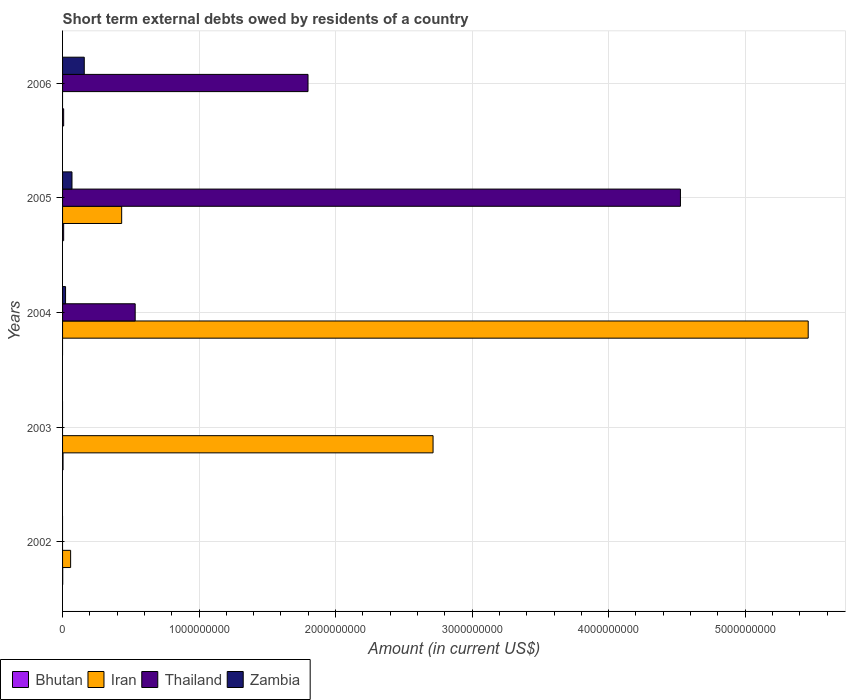How many groups of bars are there?
Offer a very short reply. 5. Are the number of bars per tick equal to the number of legend labels?
Give a very brief answer. No. Are the number of bars on each tick of the Y-axis equal?
Give a very brief answer. No. How many bars are there on the 2nd tick from the top?
Offer a terse response. 4. What is the amount of short-term external debts owed by residents in Thailand in 2005?
Your response must be concise. 4.53e+09. Across all years, what is the minimum amount of short-term external debts owed by residents in Bhutan?
Offer a very short reply. 0. What is the total amount of short-term external debts owed by residents in Thailand in the graph?
Give a very brief answer. 6.86e+09. What is the difference between the amount of short-term external debts owed by residents in Iran in 2002 and that in 2005?
Offer a terse response. -3.74e+08. What is the difference between the amount of short-term external debts owed by residents in Iran in 2004 and the amount of short-term external debts owed by residents in Bhutan in 2005?
Make the answer very short. 5.45e+09. What is the average amount of short-term external debts owed by residents in Thailand per year?
Your answer should be compact. 1.37e+09. In the year 2005, what is the difference between the amount of short-term external debts owed by residents in Thailand and amount of short-term external debts owed by residents in Bhutan?
Your response must be concise. 4.52e+09. What is the ratio of the amount of short-term external debts owed by residents in Zambia in 2004 to that in 2006?
Provide a short and direct response. 0.14. Is the difference between the amount of short-term external debts owed by residents in Thailand in 2005 and 2006 greater than the difference between the amount of short-term external debts owed by residents in Bhutan in 2005 and 2006?
Ensure brevity in your answer.  Yes. What is the difference between the highest and the lowest amount of short-term external debts owed by residents in Zambia?
Provide a succinct answer. 1.59e+08. Is it the case that in every year, the sum of the amount of short-term external debts owed by residents in Iran and amount of short-term external debts owed by residents in Bhutan is greater than the sum of amount of short-term external debts owed by residents in Zambia and amount of short-term external debts owed by residents in Thailand?
Provide a short and direct response. No. Is it the case that in every year, the sum of the amount of short-term external debts owed by residents in Iran and amount of short-term external debts owed by residents in Bhutan is greater than the amount of short-term external debts owed by residents in Thailand?
Provide a short and direct response. No. Are all the bars in the graph horizontal?
Your answer should be compact. Yes. Does the graph contain any zero values?
Your response must be concise. Yes. Does the graph contain grids?
Keep it short and to the point. Yes. Where does the legend appear in the graph?
Provide a short and direct response. Bottom left. How many legend labels are there?
Provide a short and direct response. 4. How are the legend labels stacked?
Make the answer very short. Horizontal. What is the title of the graph?
Make the answer very short. Short term external debts owed by residents of a country. Does "Myanmar" appear as one of the legend labels in the graph?
Your answer should be very brief. No. What is the label or title of the X-axis?
Offer a terse response. Amount (in current US$). What is the Amount (in current US$) in Bhutan in 2002?
Offer a very short reply. 9.93e+05. What is the Amount (in current US$) in Iran in 2002?
Your answer should be very brief. 5.90e+07. What is the Amount (in current US$) of Thailand in 2002?
Provide a short and direct response. 0. What is the Amount (in current US$) in Bhutan in 2003?
Your response must be concise. 3.38e+06. What is the Amount (in current US$) in Iran in 2003?
Make the answer very short. 2.71e+09. What is the Amount (in current US$) of Bhutan in 2004?
Give a very brief answer. 0. What is the Amount (in current US$) of Iran in 2004?
Provide a succinct answer. 5.46e+09. What is the Amount (in current US$) in Thailand in 2004?
Keep it short and to the point. 5.32e+08. What is the Amount (in current US$) in Zambia in 2004?
Offer a terse response. 2.20e+07. What is the Amount (in current US$) of Bhutan in 2005?
Provide a short and direct response. 8.00e+06. What is the Amount (in current US$) in Iran in 2005?
Offer a terse response. 4.33e+08. What is the Amount (in current US$) of Thailand in 2005?
Your answer should be very brief. 4.53e+09. What is the Amount (in current US$) in Zambia in 2005?
Offer a very short reply. 6.90e+07. What is the Amount (in current US$) in Thailand in 2006?
Provide a succinct answer. 1.80e+09. What is the Amount (in current US$) in Zambia in 2006?
Give a very brief answer. 1.59e+08. Across all years, what is the maximum Amount (in current US$) in Iran?
Provide a succinct answer. 5.46e+09. Across all years, what is the maximum Amount (in current US$) in Thailand?
Provide a succinct answer. 4.53e+09. Across all years, what is the maximum Amount (in current US$) of Zambia?
Give a very brief answer. 1.59e+08. Across all years, what is the minimum Amount (in current US$) of Thailand?
Keep it short and to the point. 0. What is the total Amount (in current US$) in Bhutan in the graph?
Give a very brief answer. 2.04e+07. What is the total Amount (in current US$) in Iran in the graph?
Offer a very short reply. 8.67e+09. What is the total Amount (in current US$) in Thailand in the graph?
Provide a succinct answer. 6.86e+09. What is the total Amount (in current US$) in Zambia in the graph?
Offer a very short reply. 2.50e+08. What is the difference between the Amount (in current US$) of Bhutan in 2002 and that in 2003?
Provide a succinct answer. -2.38e+06. What is the difference between the Amount (in current US$) of Iran in 2002 and that in 2003?
Provide a short and direct response. -2.66e+09. What is the difference between the Amount (in current US$) of Iran in 2002 and that in 2004?
Keep it short and to the point. -5.40e+09. What is the difference between the Amount (in current US$) in Bhutan in 2002 and that in 2005?
Keep it short and to the point. -7.01e+06. What is the difference between the Amount (in current US$) in Iran in 2002 and that in 2005?
Offer a very short reply. -3.74e+08. What is the difference between the Amount (in current US$) of Bhutan in 2002 and that in 2006?
Offer a very short reply. -7.01e+06. What is the difference between the Amount (in current US$) in Iran in 2003 and that in 2004?
Give a very brief answer. -2.75e+09. What is the difference between the Amount (in current US$) of Bhutan in 2003 and that in 2005?
Make the answer very short. -4.62e+06. What is the difference between the Amount (in current US$) in Iran in 2003 and that in 2005?
Offer a terse response. 2.28e+09. What is the difference between the Amount (in current US$) of Bhutan in 2003 and that in 2006?
Provide a succinct answer. -4.62e+06. What is the difference between the Amount (in current US$) of Iran in 2004 and that in 2005?
Your answer should be very brief. 5.03e+09. What is the difference between the Amount (in current US$) of Thailand in 2004 and that in 2005?
Your response must be concise. -3.99e+09. What is the difference between the Amount (in current US$) of Zambia in 2004 and that in 2005?
Offer a very short reply. -4.70e+07. What is the difference between the Amount (in current US$) in Thailand in 2004 and that in 2006?
Make the answer very short. -1.27e+09. What is the difference between the Amount (in current US$) in Zambia in 2004 and that in 2006?
Make the answer very short. -1.37e+08. What is the difference between the Amount (in current US$) in Bhutan in 2005 and that in 2006?
Provide a short and direct response. 0. What is the difference between the Amount (in current US$) in Thailand in 2005 and that in 2006?
Keep it short and to the point. 2.73e+09. What is the difference between the Amount (in current US$) of Zambia in 2005 and that in 2006?
Make the answer very short. -9.00e+07. What is the difference between the Amount (in current US$) in Bhutan in 2002 and the Amount (in current US$) in Iran in 2003?
Your answer should be very brief. -2.71e+09. What is the difference between the Amount (in current US$) in Bhutan in 2002 and the Amount (in current US$) in Iran in 2004?
Offer a very short reply. -5.46e+09. What is the difference between the Amount (in current US$) of Bhutan in 2002 and the Amount (in current US$) of Thailand in 2004?
Give a very brief answer. -5.31e+08. What is the difference between the Amount (in current US$) of Bhutan in 2002 and the Amount (in current US$) of Zambia in 2004?
Offer a very short reply. -2.10e+07. What is the difference between the Amount (in current US$) in Iran in 2002 and the Amount (in current US$) in Thailand in 2004?
Offer a terse response. -4.73e+08. What is the difference between the Amount (in current US$) in Iran in 2002 and the Amount (in current US$) in Zambia in 2004?
Your answer should be very brief. 3.70e+07. What is the difference between the Amount (in current US$) in Bhutan in 2002 and the Amount (in current US$) in Iran in 2005?
Keep it short and to the point. -4.32e+08. What is the difference between the Amount (in current US$) in Bhutan in 2002 and the Amount (in current US$) in Thailand in 2005?
Offer a terse response. -4.53e+09. What is the difference between the Amount (in current US$) of Bhutan in 2002 and the Amount (in current US$) of Zambia in 2005?
Your answer should be very brief. -6.80e+07. What is the difference between the Amount (in current US$) of Iran in 2002 and the Amount (in current US$) of Thailand in 2005?
Your answer should be compact. -4.47e+09. What is the difference between the Amount (in current US$) in Iran in 2002 and the Amount (in current US$) in Zambia in 2005?
Give a very brief answer. -1.00e+07. What is the difference between the Amount (in current US$) in Bhutan in 2002 and the Amount (in current US$) in Thailand in 2006?
Ensure brevity in your answer.  -1.80e+09. What is the difference between the Amount (in current US$) of Bhutan in 2002 and the Amount (in current US$) of Zambia in 2006?
Provide a succinct answer. -1.58e+08. What is the difference between the Amount (in current US$) in Iran in 2002 and the Amount (in current US$) in Thailand in 2006?
Your answer should be very brief. -1.74e+09. What is the difference between the Amount (in current US$) of Iran in 2002 and the Amount (in current US$) of Zambia in 2006?
Give a very brief answer. -1.00e+08. What is the difference between the Amount (in current US$) of Bhutan in 2003 and the Amount (in current US$) of Iran in 2004?
Provide a succinct answer. -5.46e+09. What is the difference between the Amount (in current US$) of Bhutan in 2003 and the Amount (in current US$) of Thailand in 2004?
Your response must be concise. -5.29e+08. What is the difference between the Amount (in current US$) in Bhutan in 2003 and the Amount (in current US$) in Zambia in 2004?
Keep it short and to the point. -1.86e+07. What is the difference between the Amount (in current US$) in Iran in 2003 and the Amount (in current US$) in Thailand in 2004?
Keep it short and to the point. 2.18e+09. What is the difference between the Amount (in current US$) of Iran in 2003 and the Amount (in current US$) of Zambia in 2004?
Your response must be concise. 2.69e+09. What is the difference between the Amount (in current US$) of Bhutan in 2003 and the Amount (in current US$) of Iran in 2005?
Give a very brief answer. -4.30e+08. What is the difference between the Amount (in current US$) of Bhutan in 2003 and the Amount (in current US$) of Thailand in 2005?
Your answer should be very brief. -4.52e+09. What is the difference between the Amount (in current US$) in Bhutan in 2003 and the Amount (in current US$) in Zambia in 2005?
Provide a succinct answer. -6.56e+07. What is the difference between the Amount (in current US$) in Iran in 2003 and the Amount (in current US$) in Thailand in 2005?
Offer a very short reply. -1.81e+09. What is the difference between the Amount (in current US$) in Iran in 2003 and the Amount (in current US$) in Zambia in 2005?
Provide a succinct answer. 2.64e+09. What is the difference between the Amount (in current US$) of Bhutan in 2003 and the Amount (in current US$) of Thailand in 2006?
Keep it short and to the point. -1.79e+09. What is the difference between the Amount (in current US$) in Bhutan in 2003 and the Amount (in current US$) in Zambia in 2006?
Make the answer very short. -1.56e+08. What is the difference between the Amount (in current US$) in Iran in 2003 and the Amount (in current US$) in Thailand in 2006?
Your response must be concise. 9.16e+08. What is the difference between the Amount (in current US$) in Iran in 2003 and the Amount (in current US$) in Zambia in 2006?
Ensure brevity in your answer.  2.56e+09. What is the difference between the Amount (in current US$) of Iran in 2004 and the Amount (in current US$) of Thailand in 2005?
Your response must be concise. 9.36e+08. What is the difference between the Amount (in current US$) in Iran in 2004 and the Amount (in current US$) in Zambia in 2005?
Ensure brevity in your answer.  5.39e+09. What is the difference between the Amount (in current US$) of Thailand in 2004 and the Amount (in current US$) of Zambia in 2005?
Your answer should be compact. 4.63e+08. What is the difference between the Amount (in current US$) in Iran in 2004 and the Amount (in current US$) in Thailand in 2006?
Your response must be concise. 3.66e+09. What is the difference between the Amount (in current US$) of Iran in 2004 and the Amount (in current US$) of Zambia in 2006?
Make the answer very short. 5.30e+09. What is the difference between the Amount (in current US$) in Thailand in 2004 and the Amount (in current US$) in Zambia in 2006?
Make the answer very short. 3.73e+08. What is the difference between the Amount (in current US$) in Bhutan in 2005 and the Amount (in current US$) in Thailand in 2006?
Provide a succinct answer. -1.79e+09. What is the difference between the Amount (in current US$) in Bhutan in 2005 and the Amount (in current US$) in Zambia in 2006?
Give a very brief answer. -1.51e+08. What is the difference between the Amount (in current US$) in Iran in 2005 and the Amount (in current US$) in Thailand in 2006?
Your answer should be compact. -1.36e+09. What is the difference between the Amount (in current US$) in Iran in 2005 and the Amount (in current US$) in Zambia in 2006?
Offer a very short reply. 2.74e+08. What is the difference between the Amount (in current US$) of Thailand in 2005 and the Amount (in current US$) of Zambia in 2006?
Make the answer very short. 4.37e+09. What is the average Amount (in current US$) in Bhutan per year?
Keep it short and to the point. 4.07e+06. What is the average Amount (in current US$) of Iran per year?
Ensure brevity in your answer.  1.73e+09. What is the average Amount (in current US$) of Thailand per year?
Keep it short and to the point. 1.37e+09. In the year 2002, what is the difference between the Amount (in current US$) of Bhutan and Amount (in current US$) of Iran?
Give a very brief answer. -5.80e+07. In the year 2003, what is the difference between the Amount (in current US$) of Bhutan and Amount (in current US$) of Iran?
Keep it short and to the point. -2.71e+09. In the year 2004, what is the difference between the Amount (in current US$) of Iran and Amount (in current US$) of Thailand?
Your answer should be compact. 4.93e+09. In the year 2004, what is the difference between the Amount (in current US$) in Iran and Amount (in current US$) in Zambia?
Make the answer very short. 5.44e+09. In the year 2004, what is the difference between the Amount (in current US$) in Thailand and Amount (in current US$) in Zambia?
Your answer should be very brief. 5.10e+08. In the year 2005, what is the difference between the Amount (in current US$) of Bhutan and Amount (in current US$) of Iran?
Provide a succinct answer. -4.25e+08. In the year 2005, what is the difference between the Amount (in current US$) in Bhutan and Amount (in current US$) in Thailand?
Your answer should be very brief. -4.52e+09. In the year 2005, what is the difference between the Amount (in current US$) of Bhutan and Amount (in current US$) of Zambia?
Your answer should be compact. -6.10e+07. In the year 2005, what is the difference between the Amount (in current US$) in Iran and Amount (in current US$) in Thailand?
Your response must be concise. -4.09e+09. In the year 2005, what is the difference between the Amount (in current US$) of Iran and Amount (in current US$) of Zambia?
Make the answer very short. 3.64e+08. In the year 2005, what is the difference between the Amount (in current US$) in Thailand and Amount (in current US$) in Zambia?
Provide a succinct answer. 4.46e+09. In the year 2006, what is the difference between the Amount (in current US$) of Bhutan and Amount (in current US$) of Thailand?
Provide a short and direct response. -1.79e+09. In the year 2006, what is the difference between the Amount (in current US$) of Bhutan and Amount (in current US$) of Zambia?
Make the answer very short. -1.51e+08. In the year 2006, what is the difference between the Amount (in current US$) in Thailand and Amount (in current US$) in Zambia?
Your response must be concise. 1.64e+09. What is the ratio of the Amount (in current US$) in Bhutan in 2002 to that in 2003?
Ensure brevity in your answer.  0.29. What is the ratio of the Amount (in current US$) of Iran in 2002 to that in 2003?
Your response must be concise. 0.02. What is the ratio of the Amount (in current US$) in Iran in 2002 to that in 2004?
Offer a very short reply. 0.01. What is the ratio of the Amount (in current US$) of Bhutan in 2002 to that in 2005?
Provide a succinct answer. 0.12. What is the ratio of the Amount (in current US$) of Iran in 2002 to that in 2005?
Your answer should be very brief. 0.14. What is the ratio of the Amount (in current US$) in Bhutan in 2002 to that in 2006?
Give a very brief answer. 0.12. What is the ratio of the Amount (in current US$) in Iran in 2003 to that in 2004?
Your answer should be compact. 0.5. What is the ratio of the Amount (in current US$) in Bhutan in 2003 to that in 2005?
Provide a succinct answer. 0.42. What is the ratio of the Amount (in current US$) in Iran in 2003 to that in 2005?
Your response must be concise. 6.27. What is the ratio of the Amount (in current US$) of Bhutan in 2003 to that in 2006?
Offer a very short reply. 0.42. What is the ratio of the Amount (in current US$) of Iran in 2004 to that in 2005?
Provide a succinct answer. 12.61. What is the ratio of the Amount (in current US$) in Thailand in 2004 to that in 2005?
Ensure brevity in your answer.  0.12. What is the ratio of the Amount (in current US$) of Zambia in 2004 to that in 2005?
Give a very brief answer. 0.32. What is the ratio of the Amount (in current US$) in Thailand in 2004 to that in 2006?
Give a very brief answer. 0.3. What is the ratio of the Amount (in current US$) in Zambia in 2004 to that in 2006?
Offer a very short reply. 0.14. What is the ratio of the Amount (in current US$) in Bhutan in 2005 to that in 2006?
Ensure brevity in your answer.  1. What is the ratio of the Amount (in current US$) in Thailand in 2005 to that in 2006?
Ensure brevity in your answer.  2.52. What is the ratio of the Amount (in current US$) of Zambia in 2005 to that in 2006?
Offer a terse response. 0.43. What is the difference between the highest and the second highest Amount (in current US$) of Bhutan?
Ensure brevity in your answer.  0. What is the difference between the highest and the second highest Amount (in current US$) in Iran?
Provide a succinct answer. 2.75e+09. What is the difference between the highest and the second highest Amount (in current US$) in Thailand?
Ensure brevity in your answer.  2.73e+09. What is the difference between the highest and the second highest Amount (in current US$) in Zambia?
Make the answer very short. 9.00e+07. What is the difference between the highest and the lowest Amount (in current US$) of Iran?
Offer a very short reply. 5.46e+09. What is the difference between the highest and the lowest Amount (in current US$) in Thailand?
Provide a succinct answer. 4.53e+09. What is the difference between the highest and the lowest Amount (in current US$) of Zambia?
Keep it short and to the point. 1.59e+08. 